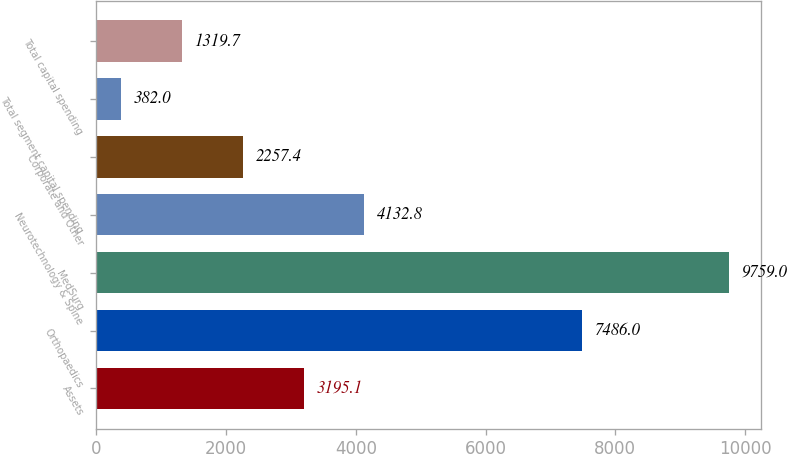<chart> <loc_0><loc_0><loc_500><loc_500><bar_chart><fcel>Assets<fcel>Orthopaedics<fcel>MedSurg<fcel>Neurotechnology & Spine<fcel>Corporate and Other<fcel>Total segment capital spending<fcel>Total capital spending<nl><fcel>3195.1<fcel>7486<fcel>9759<fcel>4132.8<fcel>2257.4<fcel>382<fcel>1319.7<nl></chart> 